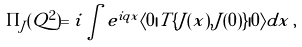Convert formula to latex. <formula><loc_0><loc_0><loc_500><loc_500>\Pi _ { J } ( Q ^ { 2 } ) = i \int e ^ { i q x } \langle 0 | T \{ J ( x ) , J ( 0 ) \} | 0 \rangle d x \, ,</formula> 